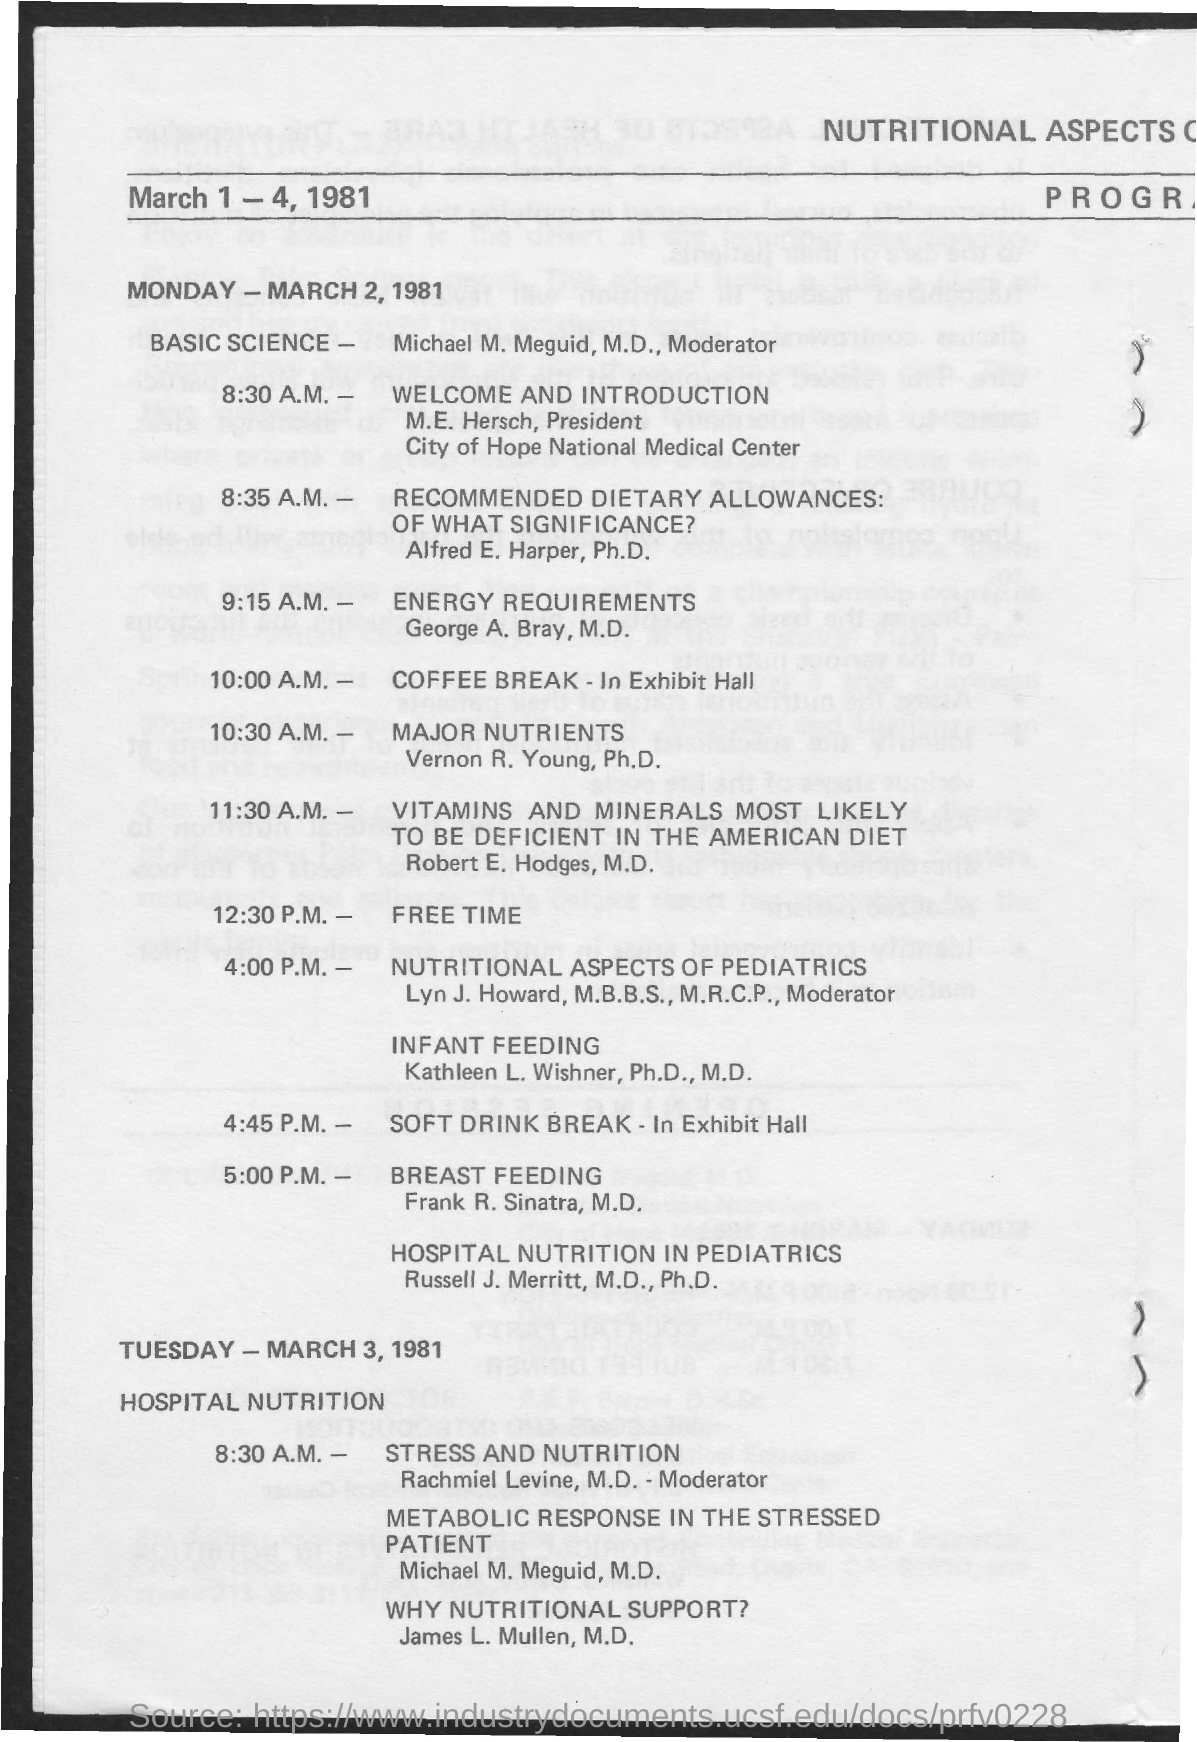Who is the president of the city of hope national medical center?
Offer a terse response. M.E. Hersch. What is the session after the coffee break?
Offer a very short reply. Major nutrients. Coffee break is at which time?
Provide a short and direct response. 10:00 a.m. 